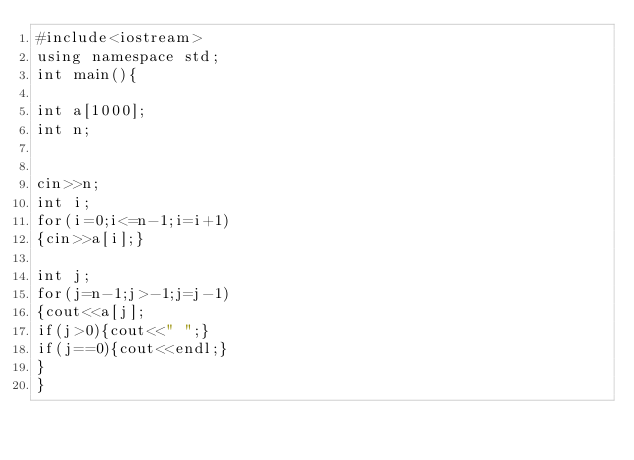Convert code to text. <code><loc_0><loc_0><loc_500><loc_500><_C++_>#include<iostream>
using namespace std;
int main(){

int a[1000];
int n;


cin>>n;
int i;
for(i=0;i<=n-1;i=i+1)
{cin>>a[i];}

int j;
for(j=n-1;j>-1;j=j-1)
{cout<<a[j];
if(j>0){cout<<" ";}
if(j==0){cout<<endl;}
}
}
</code> 